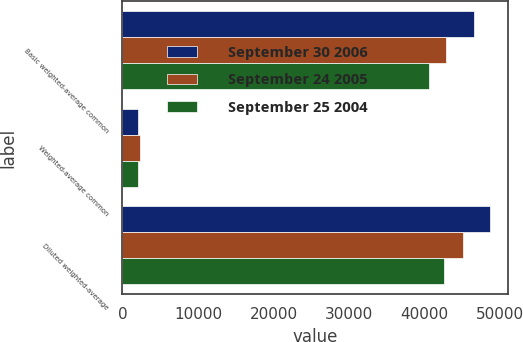Convert chart to OTSL. <chart><loc_0><loc_0><loc_500><loc_500><stacked_bar_chart><ecel><fcel>Basic weighted-average common<fcel>Weighted-average common<fcel>Diluted weighted-average<nl><fcel>September 30 2006<fcel>46512<fcel>2108<fcel>48620<nl><fcel>September 24 2005<fcel>42824<fcel>2302<fcel>45126<nl><fcel>September 25 2004<fcel>40516<fcel>2077<fcel>42593<nl></chart> 